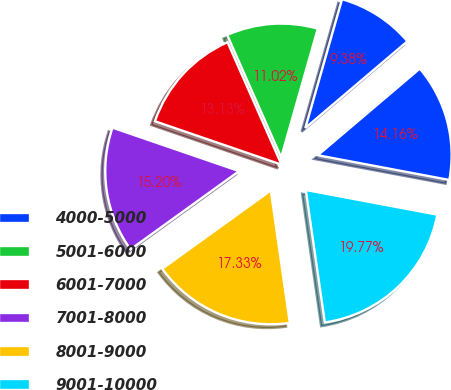Convert chart. <chart><loc_0><loc_0><loc_500><loc_500><pie_chart><fcel>4000-5000<fcel>5001-6000<fcel>6001-7000<fcel>7001-8000<fcel>8001-9000<fcel>9001-10000<fcel>Total<nl><fcel>9.38%<fcel>11.02%<fcel>13.13%<fcel>15.2%<fcel>17.33%<fcel>19.77%<fcel>14.16%<nl></chart> 